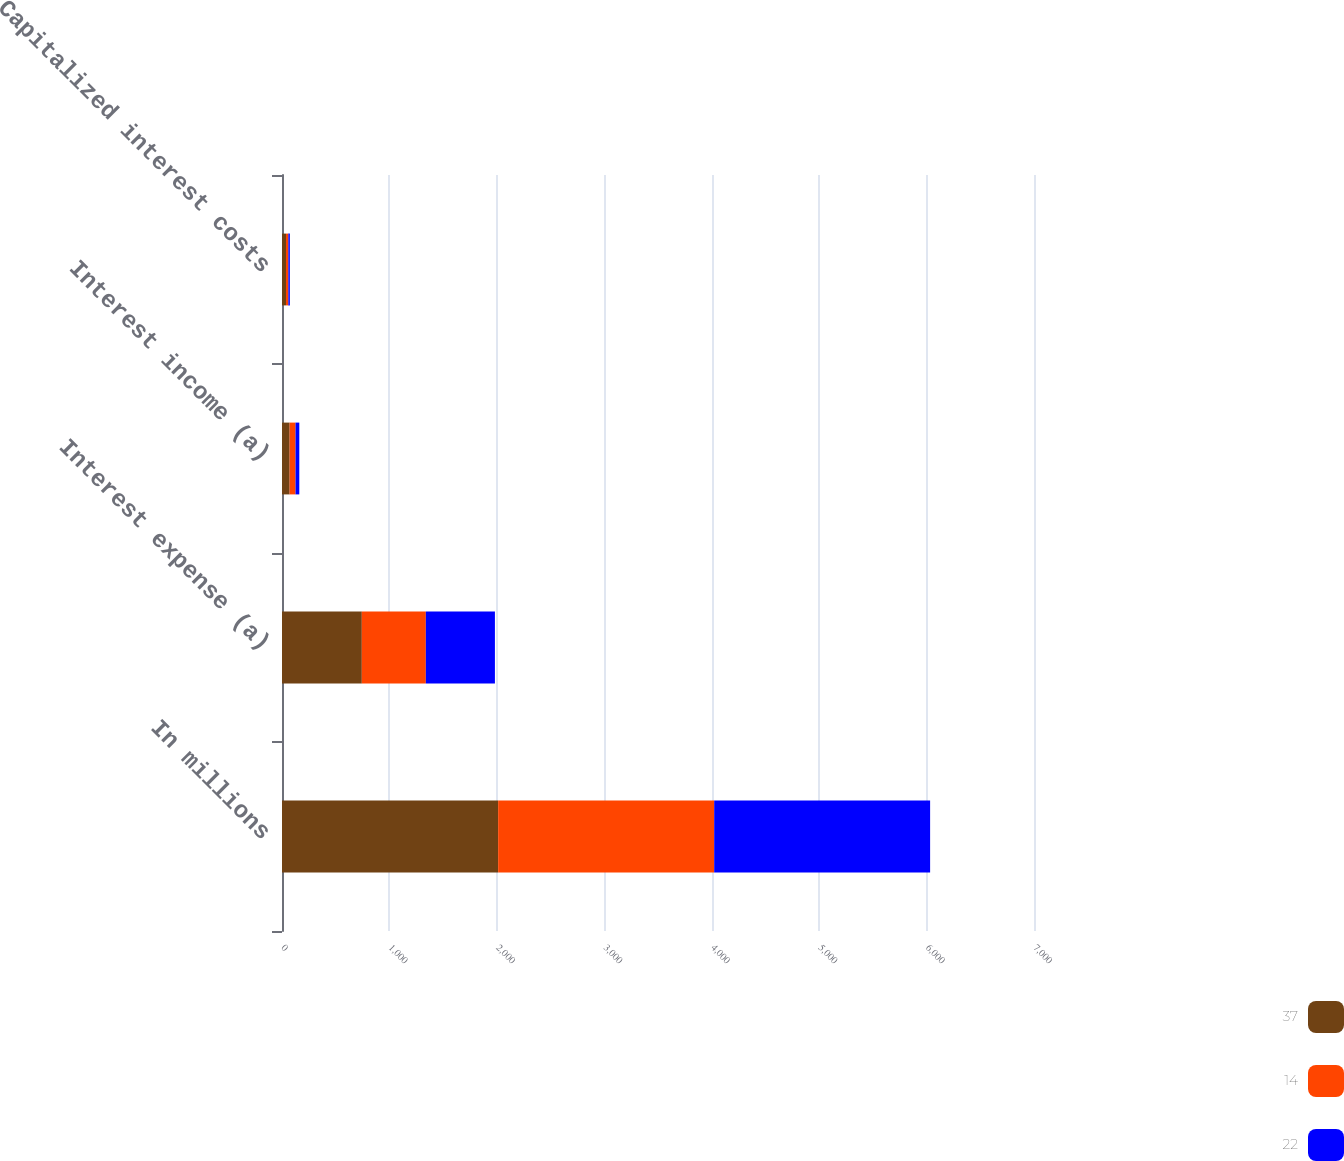<chart> <loc_0><loc_0><loc_500><loc_500><stacked_bar_chart><ecel><fcel>In millions<fcel>Interest expense (a)<fcel>Interest income (a)<fcel>Capitalized interest costs<nl><fcel>37<fcel>2012<fcel>743<fcel>71<fcel>37<nl><fcel>14<fcel>2011<fcel>596<fcel>55<fcel>22<nl><fcel>22<fcel>2010<fcel>643<fcel>35<fcel>14<nl></chart> 